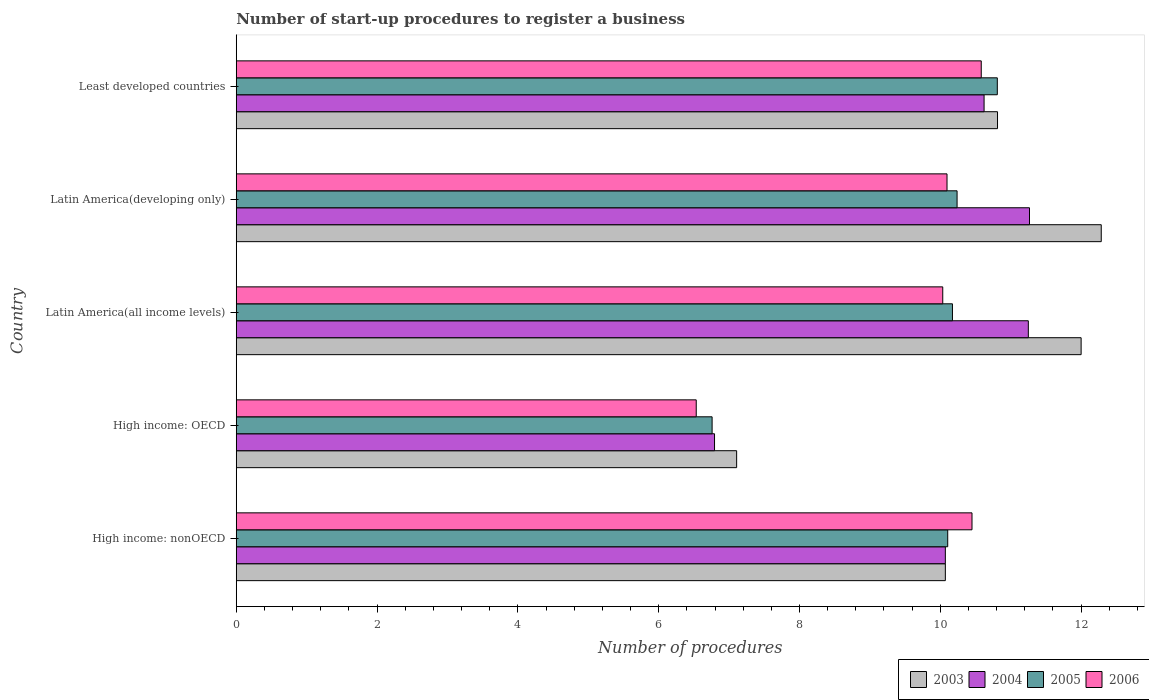How many different coloured bars are there?
Your answer should be very brief. 4. How many groups of bars are there?
Your answer should be very brief. 5. Are the number of bars on each tick of the Y-axis equal?
Provide a succinct answer. Yes. How many bars are there on the 1st tick from the top?
Make the answer very short. 4. How many bars are there on the 5th tick from the bottom?
Provide a short and direct response. 4. What is the label of the 1st group of bars from the top?
Make the answer very short. Least developed countries. In how many cases, is the number of bars for a given country not equal to the number of legend labels?
Keep it short and to the point. 0. What is the number of procedures required to register a business in 2006 in Latin America(all income levels)?
Provide a succinct answer. 10.03. Across all countries, what is the maximum number of procedures required to register a business in 2003?
Offer a terse response. 12.29. Across all countries, what is the minimum number of procedures required to register a business in 2005?
Offer a terse response. 6.76. In which country was the number of procedures required to register a business in 2006 maximum?
Ensure brevity in your answer.  Least developed countries. In which country was the number of procedures required to register a business in 2004 minimum?
Offer a very short reply. High income: OECD. What is the total number of procedures required to register a business in 2004 in the graph?
Your answer should be compact. 50. What is the difference between the number of procedures required to register a business in 2006 in High income: OECD and that in Latin America(developing only)?
Keep it short and to the point. -3.56. What is the difference between the number of procedures required to register a business in 2005 in Latin America(all income levels) and the number of procedures required to register a business in 2006 in Latin America(developing only)?
Your response must be concise. 0.08. What is the average number of procedures required to register a business in 2005 per country?
Provide a succinct answer. 9.62. What is the difference between the number of procedures required to register a business in 2003 and number of procedures required to register a business in 2006 in Latin America(developing only)?
Keep it short and to the point. 2.19. What is the ratio of the number of procedures required to register a business in 2003 in High income: OECD to that in Latin America(developing only)?
Provide a succinct answer. 0.58. What is the difference between the highest and the second highest number of procedures required to register a business in 2004?
Provide a succinct answer. 0.02. What is the difference between the highest and the lowest number of procedures required to register a business in 2005?
Offer a very short reply. 4.05. In how many countries, is the number of procedures required to register a business in 2005 greater than the average number of procedures required to register a business in 2005 taken over all countries?
Your answer should be compact. 4. Is the sum of the number of procedures required to register a business in 2005 in High income: OECD and Latin America(developing only) greater than the maximum number of procedures required to register a business in 2003 across all countries?
Offer a terse response. Yes. Is it the case that in every country, the sum of the number of procedures required to register a business in 2003 and number of procedures required to register a business in 2006 is greater than the sum of number of procedures required to register a business in 2004 and number of procedures required to register a business in 2005?
Offer a terse response. No. Is it the case that in every country, the sum of the number of procedures required to register a business in 2004 and number of procedures required to register a business in 2006 is greater than the number of procedures required to register a business in 2003?
Provide a succinct answer. Yes. How many bars are there?
Keep it short and to the point. 20. Are all the bars in the graph horizontal?
Ensure brevity in your answer.  Yes. How many countries are there in the graph?
Make the answer very short. 5. Are the values on the major ticks of X-axis written in scientific E-notation?
Keep it short and to the point. No. Does the graph contain grids?
Provide a succinct answer. No. How many legend labels are there?
Keep it short and to the point. 4. How are the legend labels stacked?
Keep it short and to the point. Horizontal. What is the title of the graph?
Your response must be concise. Number of start-up procedures to register a business. Does "1975" appear as one of the legend labels in the graph?
Offer a very short reply. No. What is the label or title of the X-axis?
Offer a terse response. Number of procedures. What is the label or title of the Y-axis?
Your answer should be compact. Country. What is the Number of procedures in 2003 in High income: nonOECD?
Your answer should be compact. 10.07. What is the Number of procedures in 2004 in High income: nonOECD?
Give a very brief answer. 10.07. What is the Number of procedures of 2005 in High income: nonOECD?
Your answer should be compact. 10.11. What is the Number of procedures of 2006 in High income: nonOECD?
Provide a succinct answer. 10.45. What is the Number of procedures in 2003 in High income: OECD?
Offer a very short reply. 7.11. What is the Number of procedures of 2004 in High income: OECD?
Keep it short and to the point. 6.79. What is the Number of procedures in 2005 in High income: OECD?
Offer a terse response. 6.76. What is the Number of procedures of 2006 in High income: OECD?
Provide a short and direct response. 6.53. What is the Number of procedures of 2004 in Latin America(all income levels)?
Your response must be concise. 11.25. What is the Number of procedures of 2005 in Latin America(all income levels)?
Ensure brevity in your answer.  10.17. What is the Number of procedures of 2006 in Latin America(all income levels)?
Provide a succinct answer. 10.03. What is the Number of procedures in 2003 in Latin America(developing only)?
Your answer should be compact. 12.29. What is the Number of procedures of 2004 in Latin America(developing only)?
Your answer should be very brief. 11.27. What is the Number of procedures of 2005 in Latin America(developing only)?
Provide a short and direct response. 10.24. What is the Number of procedures in 2006 in Latin America(developing only)?
Provide a succinct answer. 10.1. What is the Number of procedures of 2003 in Least developed countries?
Keep it short and to the point. 10.81. What is the Number of procedures of 2004 in Least developed countries?
Your response must be concise. 10.62. What is the Number of procedures of 2005 in Least developed countries?
Provide a succinct answer. 10.81. What is the Number of procedures in 2006 in Least developed countries?
Keep it short and to the point. 10.58. Across all countries, what is the maximum Number of procedures of 2003?
Make the answer very short. 12.29. Across all countries, what is the maximum Number of procedures in 2004?
Your response must be concise. 11.27. Across all countries, what is the maximum Number of procedures in 2005?
Provide a short and direct response. 10.81. Across all countries, what is the maximum Number of procedures in 2006?
Provide a succinct answer. 10.58. Across all countries, what is the minimum Number of procedures in 2003?
Your answer should be very brief. 7.11. Across all countries, what is the minimum Number of procedures in 2004?
Give a very brief answer. 6.79. Across all countries, what is the minimum Number of procedures of 2005?
Provide a short and direct response. 6.76. Across all countries, what is the minimum Number of procedures of 2006?
Provide a succinct answer. 6.53. What is the total Number of procedures in 2003 in the graph?
Give a very brief answer. 52.28. What is the total Number of procedures of 2004 in the graph?
Offer a terse response. 50. What is the total Number of procedures in 2005 in the graph?
Give a very brief answer. 48.08. What is the total Number of procedures in 2006 in the graph?
Provide a succinct answer. 47.69. What is the difference between the Number of procedures in 2003 in High income: nonOECD and that in High income: OECD?
Give a very brief answer. 2.96. What is the difference between the Number of procedures of 2004 in High income: nonOECD and that in High income: OECD?
Provide a short and direct response. 3.28. What is the difference between the Number of procedures in 2005 in High income: nonOECD and that in High income: OECD?
Give a very brief answer. 3.35. What is the difference between the Number of procedures in 2006 in High income: nonOECD and that in High income: OECD?
Your answer should be compact. 3.92. What is the difference between the Number of procedures in 2003 in High income: nonOECD and that in Latin America(all income levels)?
Make the answer very short. -1.93. What is the difference between the Number of procedures in 2004 in High income: nonOECD and that in Latin America(all income levels)?
Offer a very short reply. -1.18. What is the difference between the Number of procedures in 2005 in High income: nonOECD and that in Latin America(all income levels)?
Provide a succinct answer. -0.07. What is the difference between the Number of procedures in 2006 in High income: nonOECD and that in Latin America(all income levels)?
Make the answer very short. 0.42. What is the difference between the Number of procedures in 2003 in High income: nonOECD and that in Latin America(developing only)?
Offer a terse response. -2.21. What is the difference between the Number of procedures of 2004 in High income: nonOECD and that in Latin America(developing only)?
Offer a terse response. -1.2. What is the difference between the Number of procedures in 2005 in High income: nonOECD and that in Latin America(developing only)?
Offer a very short reply. -0.13. What is the difference between the Number of procedures in 2006 in High income: nonOECD and that in Latin America(developing only)?
Provide a short and direct response. 0.35. What is the difference between the Number of procedures of 2003 in High income: nonOECD and that in Least developed countries?
Ensure brevity in your answer.  -0.74. What is the difference between the Number of procedures of 2004 in High income: nonOECD and that in Least developed countries?
Give a very brief answer. -0.55. What is the difference between the Number of procedures of 2005 in High income: nonOECD and that in Least developed countries?
Provide a succinct answer. -0.7. What is the difference between the Number of procedures of 2006 in High income: nonOECD and that in Least developed countries?
Give a very brief answer. -0.13. What is the difference between the Number of procedures of 2003 in High income: OECD and that in Latin America(all income levels)?
Provide a short and direct response. -4.89. What is the difference between the Number of procedures of 2004 in High income: OECD and that in Latin America(all income levels)?
Offer a very short reply. -4.46. What is the difference between the Number of procedures in 2005 in High income: OECD and that in Latin America(all income levels)?
Your answer should be compact. -3.41. What is the difference between the Number of procedures of 2006 in High income: OECD and that in Latin America(all income levels)?
Your answer should be very brief. -3.5. What is the difference between the Number of procedures of 2003 in High income: OECD and that in Latin America(developing only)?
Offer a very short reply. -5.18. What is the difference between the Number of procedures in 2004 in High income: OECD and that in Latin America(developing only)?
Ensure brevity in your answer.  -4.47. What is the difference between the Number of procedures in 2005 in High income: OECD and that in Latin America(developing only)?
Your response must be concise. -3.48. What is the difference between the Number of procedures in 2006 in High income: OECD and that in Latin America(developing only)?
Your response must be concise. -3.56. What is the difference between the Number of procedures in 2003 in High income: OECD and that in Least developed countries?
Offer a very short reply. -3.71. What is the difference between the Number of procedures of 2004 in High income: OECD and that in Least developed countries?
Make the answer very short. -3.83. What is the difference between the Number of procedures of 2005 in High income: OECD and that in Least developed countries?
Provide a short and direct response. -4.05. What is the difference between the Number of procedures in 2006 in High income: OECD and that in Least developed countries?
Provide a short and direct response. -4.05. What is the difference between the Number of procedures of 2003 in Latin America(all income levels) and that in Latin America(developing only)?
Provide a succinct answer. -0.29. What is the difference between the Number of procedures in 2004 in Latin America(all income levels) and that in Latin America(developing only)?
Ensure brevity in your answer.  -0.02. What is the difference between the Number of procedures of 2005 in Latin America(all income levels) and that in Latin America(developing only)?
Offer a terse response. -0.07. What is the difference between the Number of procedures of 2006 in Latin America(all income levels) and that in Latin America(developing only)?
Your answer should be compact. -0.06. What is the difference between the Number of procedures in 2003 in Latin America(all income levels) and that in Least developed countries?
Ensure brevity in your answer.  1.19. What is the difference between the Number of procedures in 2004 in Latin America(all income levels) and that in Least developed countries?
Ensure brevity in your answer.  0.63. What is the difference between the Number of procedures in 2005 in Latin America(all income levels) and that in Least developed countries?
Provide a succinct answer. -0.64. What is the difference between the Number of procedures in 2006 in Latin America(all income levels) and that in Least developed countries?
Offer a terse response. -0.55. What is the difference between the Number of procedures of 2003 in Latin America(developing only) and that in Least developed countries?
Provide a short and direct response. 1.47. What is the difference between the Number of procedures in 2004 in Latin America(developing only) and that in Least developed countries?
Your answer should be very brief. 0.65. What is the difference between the Number of procedures of 2005 in Latin America(developing only) and that in Least developed countries?
Ensure brevity in your answer.  -0.57. What is the difference between the Number of procedures in 2006 in Latin America(developing only) and that in Least developed countries?
Your answer should be very brief. -0.49. What is the difference between the Number of procedures in 2003 in High income: nonOECD and the Number of procedures in 2004 in High income: OECD?
Give a very brief answer. 3.28. What is the difference between the Number of procedures of 2003 in High income: nonOECD and the Number of procedures of 2005 in High income: OECD?
Ensure brevity in your answer.  3.31. What is the difference between the Number of procedures in 2003 in High income: nonOECD and the Number of procedures in 2006 in High income: OECD?
Offer a terse response. 3.54. What is the difference between the Number of procedures in 2004 in High income: nonOECD and the Number of procedures in 2005 in High income: OECD?
Your answer should be compact. 3.31. What is the difference between the Number of procedures in 2004 in High income: nonOECD and the Number of procedures in 2006 in High income: OECD?
Keep it short and to the point. 3.54. What is the difference between the Number of procedures of 2005 in High income: nonOECD and the Number of procedures of 2006 in High income: OECD?
Offer a very short reply. 3.57. What is the difference between the Number of procedures in 2003 in High income: nonOECD and the Number of procedures in 2004 in Latin America(all income levels)?
Your answer should be very brief. -1.18. What is the difference between the Number of procedures of 2003 in High income: nonOECD and the Number of procedures of 2005 in Latin America(all income levels)?
Ensure brevity in your answer.  -0.1. What is the difference between the Number of procedures of 2003 in High income: nonOECD and the Number of procedures of 2006 in Latin America(all income levels)?
Make the answer very short. 0.04. What is the difference between the Number of procedures in 2004 in High income: nonOECD and the Number of procedures in 2005 in Latin America(all income levels)?
Offer a very short reply. -0.1. What is the difference between the Number of procedures in 2004 in High income: nonOECD and the Number of procedures in 2006 in Latin America(all income levels)?
Offer a very short reply. 0.04. What is the difference between the Number of procedures of 2005 in High income: nonOECD and the Number of procedures of 2006 in Latin America(all income levels)?
Your answer should be very brief. 0.07. What is the difference between the Number of procedures in 2003 in High income: nonOECD and the Number of procedures in 2004 in Latin America(developing only)?
Make the answer very short. -1.2. What is the difference between the Number of procedures in 2003 in High income: nonOECD and the Number of procedures in 2006 in Latin America(developing only)?
Ensure brevity in your answer.  -0.02. What is the difference between the Number of procedures of 2004 in High income: nonOECD and the Number of procedures of 2006 in Latin America(developing only)?
Your answer should be compact. -0.02. What is the difference between the Number of procedures in 2005 in High income: nonOECD and the Number of procedures in 2006 in Latin America(developing only)?
Your answer should be compact. 0.01. What is the difference between the Number of procedures in 2003 in High income: nonOECD and the Number of procedures in 2004 in Least developed countries?
Keep it short and to the point. -0.55. What is the difference between the Number of procedures in 2003 in High income: nonOECD and the Number of procedures in 2005 in Least developed countries?
Your response must be concise. -0.74. What is the difference between the Number of procedures in 2003 in High income: nonOECD and the Number of procedures in 2006 in Least developed countries?
Ensure brevity in your answer.  -0.51. What is the difference between the Number of procedures in 2004 in High income: nonOECD and the Number of procedures in 2005 in Least developed countries?
Your answer should be compact. -0.74. What is the difference between the Number of procedures of 2004 in High income: nonOECD and the Number of procedures of 2006 in Least developed countries?
Offer a very short reply. -0.51. What is the difference between the Number of procedures in 2005 in High income: nonOECD and the Number of procedures in 2006 in Least developed countries?
Offer a very short reply. -0.48. What is the difference between the Number of procedures in 2003 in High income: OECD and the Number of procedures in 2004 in Latin America(all income levels)?
Ensure brevity in your answer.  -4.14. What is the difference between the Number of procedures in 2003 in High income: OECD and the Number of procedures in 2005 in Latin America(all income levels)?
Your answer should be compact. -3.07. What is the difference between the Number of procedures in 2003 in High income: OECD and the Number of procedures in 2006 in Latin America(all income levels)?
Provide a succinct answer. -2.93. What is the difference between the Number of procedures of 2004 in High income: OECD and the Number of procedures of 2005 in Latin America(all income levels)?
Your answer should be compact. -3.38. What is the difference between the Number of procedures of 2004 in High income: OECD and the Number of procedures of 2006 in Latin America(all income levels)?
Provide a succinct answer. -3.24. What is the difference between the Number of procedures of 2005 in High income: OECD and the Number of procedures of 2006 in Latin America(all income levels)?
Make the answer very short. -3.28. What is the difference between the Number of procedures in 2003 in High income: OECD and the Number of procedures in 2004 in Latin America(developing only)?
Keep it short and to the point. -4.16. What is the difference between the Number of procedures in 2003 in High income: OECD and the Number of procedures in 2005 in Latin America(developing only)?
Offer a very short reply. -3.13. What is the difference between the Number of procedures of 2003 in High income: OECD and the Number of procedures of 2006 in Latin America(developing only)?
Give a very brief answer. -2.99. What is the difference between the Number of procedures in 2004 in High income: OECD and the Number of procedures in 2005 in Latin America(developing only)?
Make the answer very short. -3.44. What is the difference between the Number of procedures in 2004 in High income: OECD and the Number of procedures in 2006 in Latin America(developing only)?
Give a very brief answer. -3.3. What is the difference between the Number of procedures in 2005 in High income: OECD and the Number of procedures in 2006 in Latin America(developing only)?
Offer a very short reply. -3.34. What is the difference between the Number of procedures of 2003 in High income: OECD and the Number of procedures of 2004 in Least developed countries?
Give a very brief answer. -3.51. What is the difference between the Number of procedures in 2003 in High income: OECD and the Number of procedures in 2005 in Least developed countries?
Offer a terse response. -3.7. What is the difference between the Number of procedures of 2003 in High income: OECD and the Number of procedures of 2006 in Least developed countries?
Provide a succinct answer. -3.47. What is the difference between the Number of procedures in 2004 in High income: OECD and the Number of procedures in 2005 in Least developed countries?
Ensure brevity in your answer.  -4.02. What is the difference between the Number of procedures of 2004 in High income: OECD and the Number of procedures of 2006 in Least developed countries?
Your response must be concise. -3.79. What is the difference between the Number of procedures in 2005 in High income: OECD and the Number of procedures in 2006 in Least developed countries?
Ensure brevity in your answer.  -3.82. What is the difference between the Number of procedures of 2003 in Latin America(all income levels) and the Number of procedures of 2004 in Latin America(developing only)?
Provide a short and direct response. 0.73. What is the difference between the Number of procedures in 2003 in Latin America(all income levels) and the Number of procedures in 2005 in Latin America(developing only)?
Make the answer very short. 1.76. What is the difference between the Number of procedures of 2003 in Latin America(all income levels) and the Number of procedures of 2006 in Latin America(developing only)?
Offer a terse response. 1.9. What is the difference between the Number of procedures of 2004 in Latin America(all income levels) and the Number of procedures of 2005 in Latin America(developing only)?
Provide a succinct answer. 1.01. What is the difference between the Number of procedures of 2004 in Latin America(all income levels) and the Number of procedures of 2006 in Latin America(developing only)?
Give a very brief answer. 1.15. What is the difference between the Number of procedures of 2005 in Latin America(all income levels) and the Number of procedures of 2006 in Latin America(developing only)?
Your response must be concise. 0.08. What is the difference between the Number of procedures in 2003 in Latin America(all income levels) and the Number of procedures in 2004 in Least developed countries?
Your answer should be compact. 1.38. What is the difference between the Number of procedures of 2003 in Latin America(all income levels) and the Number of procedures of 2005 in Least developed countries?
Provide a short and direct response. 1.19. What is the difference between the Number of procedures of 2003 in Latin America(all income levels) and the Number of procedures of 2006 in Least developed countries?
Offer a terse response. 1.42. What is the difference between the Number of procedures of 2004 in Latin America(all income levels) and the Number of procedures of 2005 in Least developed countries?
Your answer should be compact. 0.44. What is the difference between the Number of procedures of 2004 in Latin America(all income levels) and the Number of procedures of 2006 in Least developed countries?
Give a very brief answer. 0.67. What is the difference between the Number of procedures of 2005 in Latin America(all income levels) and the Number of procedures of 2006 in Least developed countries?
Ensure brevity in your answer.  -0.41. What is the difference between the Number of procedures in 2003 in Latin America(developing only) and the Number of procedures in 2004 in Least developed countries?
Give a very brief answer. 1.66. What is the difference between the Number of procedures in 2003 in Latin America(developing only) and the Number of procedures in 2005 in Least developed countries?
Ensure brevity in your answer.  1.48. What is the difference between the Number of procedures of 2003 in Latin America(developing only) and the Number of procedures of 2006 in Least developed countries?
Offer a very short reply. 1.7. What is the difference between the Number of procedures of 2004 in Latin America(developing only) and the Number of procedures of 2005 in Least developed countries?
Keep it short and to the point. 0.46. What is the difference between the Number of procedures in 2004 in Latin America(developing only) and the Number of procedures in 2006 in Least developed countries?
Provide a short and direct response. 0.69. What is the difference between the Number of procedures in 2005 in Latin America(developing only) and the Number of procedures in 2006 in Least developed countries?
Provide a short and direct response. -0.34. What is the average Number of procedures in 2003 per country?
Give a very brief answer. 10.46. What is the average Number of procedures in 2004 per country?
Ensure brevity in your answer.  10. What is the average Number of procedures of 2005 per country?
Provide a succinct answer. 9.62. What is the average Number of procedures in 2006 per country?
Ensure brevity in your answer.  9.54. What is the difference between the Number of procedures in 2003 and Number of procedures in 2004 in High income: nonOECD?
Provide a succinct answer. 0. What is the difference between the Number of procedures of 2003 and Number of procedures of 2005 in High income: nonOECD?
Provide a succinct answer. -0.03. What is the difference between the Number of procedures in 2003 and Number of procedures in 2006 in High income: nonOECD?
Make the answer very short. -0.38. What is the difference between the Number of procedures of 2004 and Number of procedures of 2005 in High income: nonOECD?
Offer a very short reply. -0.03. What is the difference between the Number of procedures of 2004 and Number of procedures of 2006 in High income: nonOECD?
Provide a short and direct response. -0.38. What is the difference between the Number of procedures of 2005 and Number of procedures of 2006 in High income: nonOECD?
Make the answer very short. -0.34. What is the difference between the Number of procedures in 2003 and Number of procedures in 2004 in High income: OECD?
Your answer should be compact. 0.31. What is the difference between the Number of procedures in 2003 and Number of procedures in 2005 in High income: OECD?
Provide a succinct answer. 0.35. What is the difference between the Number of procedures in 2003 and Number of procedures in 2006 in High income: OECD?
Your response must be concise. 0.57. What is the difference between the Number of procedures of 2004 and Number of procedures of 2005 in High income: OECD?
Your answer should be very brief. 0.03. What is the difference between the Number of procedures of 2004 and Number of procedures of 2006 in High income: OECD?
Ensure brevity in your answer.  0.26. What is the difference between the Number of procedures of 2005 and Number of procedures of 2006 in High income: OECD?
Your answer should be compact. 0.23. What is the difference between the Number of procedures in 2003 and Number of procedures in 2004 in Latin America(all income levels)?
Offer a very short reply. 0.75. What is the difference between the Number of procedures of 2003 and Number of procedures of 2005 in Latin America(all income levels)?
Give a very brief answer. 1.83. What is the difference between the Number of procedures of 2003 and Number of procedures of 2006 in Latin America(all income levels)?
Ensure brevity in your answer.  1.97. What is the difference between the Number of procedures of 2004 and Number of procedures of 2005 in Latin America(all income levels)?
Offer a very short reply. 1.08. What is the difference between the Number of procedures of 2004 and Number of procedures of 2006 in Latin America(all income levels)?
Your answer should be very brief. 1.22. What is the difference between the Number of procedures in 2005 and Number of procedures in 2006 in Latin America(all income levels)?
Provide a succinct answer. 0.14. What is the difference between the Number of procedures of 2003 and Number of procedures of 2005 in Latin America(developing only)?
Ensure brevity in your answer.  2.05. What is the difference between the Number of procedures of 2003 and Number of procedures of 2006 in Latin America(developing only)?
Your answer should be compact. 2.19. What is the difference between the Number of procedures of 2004 and Number of procedures of 2005 in Latin America(developing only)?
Your answer should be very brief. 1.03. What is the difference between the Number of procedures in 2004 and Number of procedures in 2006 in Latin America(developing only)?
Your answer should be very brief. 1.17. What is the difference between the Number of procedures in 2005 and Number of procedures in 2006 in Latin America(developing only)?
Your answer should be very brief. 0.14. What is the difference between the Number of procedures of 2003 and Number of procedures of 2004 in Least developed countries?
Provide a succinct answer. 0.19. What is the difference between the Number of procedures of 2003 and Number of procedures of 2005 in Least developed countries?
Your response must be concise. 0. What is the difference between the Number of procedures of 2003 and Number of procedures of 2006 in Least developed countries?
Keep it short and to the point. 0.23. What is the difference between the Number of procedures of 2004 and Number of procedures of 2005 in Least developed countries?
Make the answer very short. -0.19. What is the difference between the Number of procedures in 2004 and Number of procedures in 2006 in Least developed countries?
Your answer should be very brief. 0.04. What is the difference between the Number of procedures of 2005 and Number of procedures of 2006 in Least developed countries?
Offer a very short reply. 0.23. What is the ratio of the Number of procedures in 2003 in High income: nonOECD to that in High income: OECD?
Provide a succinct answer. 1.42. What is the ratio of the Number of procedures in 2004 in High income: nonOECD to that in High income: OECD?
Your answer should be very brief. 1.48. What is the ratio of the Number of procedures in 2005 in High income: nonOECD to that in High income: OECD?
Give a very brief answer. 1.5. What is the ratio of the Number of procedures of 2006 in High income: nonOECD to that in High income: OECD?
Your response must be concise. 1.6. What is the ratio of the Number of procedures of 2003 in High income: nonOECD to that in Latin America(all income levels)?
Give a very brief answer. 0.84. What is the ratio of the Number of procedures of 2004 in High income: nonOECD to that in Latin America(all income levels)?
Provide a short and direct response. 0.9. What is the ratio of the Number of procedures in 2005 in High income: nonOECD to that in Latin America(all income levels)?
Provide a short and direct response. 0.99. What is the ratio of the Number of procedures in 2006 in High income: nonOECD to that in Latin America(all income levels)?
Provide a short and direct response. 1.04. What is the ratio of the Number of procedures in 2003 in High income: nonOECD to that in Latin America(developing only)?
Your response must be concise. 0.82. What is the ratio of the Number of procedures of 2004 in High income: nonOECD to that in Latin America(developing only)?
Your response must be concise. 0.89. What is the ratio of the Number of procedures in 2006 in High income: nonOECD to that in Latin America(developing only)?
Provide a short and direct response. 1.04. What is the ratio of the Number of procedures in 2003 in High income: nonOECD to that in Least developed countries?
Keep it short and to the point. 0.93. What is the ratio of the Number of procedures in 2004 in High income: nonOECD to that in Least developed countries?
Provide a short and direct response. 0.95. What is the ratio of the Number of procedures in 2005 in High income: nonOECD to that in Least developed countries?
Your answer should be compact. 0.93. What is the ratio of the Number of procedures in 2006 in High income: nonOECD to that in Least developed countries?
Keep it short and to the point. 0.99. What is the ratio of the Number of procedures in 2003 in High income: OECD to that in Latin America(all income levels)?
Your answer should be compact. 0.59. What is the ratio of the Number of procedures in 2004 in High income: OECD to that in Latin America(all income levels)?
Ensure brevity in your answer.  0.6. What is the ratio of the Number of procedures of 2005 in High income: OECD to that in Latin America(all income levels)?
Provide a short and direct response. 0.66. What is the ratio of the Number of procedures of 2006 in High income: OECD to that in Latin America(all income levels)?
Make the answer very short. 0.65. What is the ratio of the Number of procedures in 2003 in High income: OECD to that in Latin America(developing only)?
Keep it short and to the point. 0.58. What is the ratio of the Number of procedures of 2004 in High income: OECD to that in Latin America(developing only)?
Ensure brevity in your answer.  0.6. What is the ratio of the Number of procedures in 2005 in High income: OECD to that in Latin America(developing only)?
Keep it short and to the point. 0.66. What is the ratio of the Number of procedures in 2006 in High income: OECD to that in Latin America(developing only)?
Your answer should be compact. 0.65. What is the ratio of the Number of procedures in 2003 in High income: OECD to that in Least developed countries?
Your answer should be very brief. 0.66. What is the ratio of the Number of procedures in 2004 in High income: OECD to that in Least developed countries?
Keep it short and to the point. 0.64. What is the ratio of the Number of procedures in 2005 in High income: OECD to that in Least developed countries?
Offer a terse response. 0.63. What is the ratio of the Number of procedures of 2006 in High income: OECD to that in Least developed countries?
Ensure brevity in your answer.  0.62. What is the ratio of the Number of procedures in 2003 in Latin America(all income levels) to that in Latin America(developing only)?
Your answer should be very brief. 0.98. What is the ratio of the Number of procedures in 2004 in Latin America(all income levels) to that in Latin America(developing only)?
Ensure brevity in your answer.  1. What is the ratio of the Number of procedures of 2006 in Latin America(all income levels) to that in Latin America(developing only)?
Provide a succinct answer. 0.99. What is the ratio of the Number of procedures of 2003 in Latin America(all income levels) to that in Least developed countries?
Provide a succinct answer. 1.11. What is the ratio of the Number of procedures in 2004 in Latin America(all income levels) to that in Least developed countries?
Give a very brief answer. 1.06. What is the ratio of the Number of procedures in 2005 in Latin America(all income levels) to that in Least developed countries?
Ensure brevity in your answer.  0.94. What is the ratio of the Number of procedures of 2006 in Latin America(all income levels) to that in Least developed countries?
Provide a succinct answer. 0.95. What is the ratio of the Number of procedures of 2003 in Latin America(developing only) to that in Least developed countries?
Your response must be concise. 1.14. What is the ratio of the Number of procedures in 2004 in Latin America(developing only) to that in Least developed countries?
Offer a very short reply. 1.06. What is the ratio of the Number of procedures in 2005 in Latin America(developing only) to that in Least developed countries?
Provide a short and direct response. 0.95. What is the ratio of the Number of procedures in 2006 in Latin America(developing only) to that in Least developed countries?
Offer a very short reply. 0.95. What is the difference between the highest and the second highest Number of procedures of 2003?
Your answer should be compact. 0.29. What is the difference between the highest and the second highest Number of procedures in 2004?
Provide a succinct answer. 0.02. What is the difference between the highest and the second highest Number of procedures in 2005?
Give a very brief answer. 0.57. What is the difference between the highest and the second highest Number of procedures of 2006?
Offer a very short reply. 0.13. What is the difference between the highest and the lowest Number of procedures of 2003?
Your answer should be very brief. 5.18. What is the difference between the highest and the lowest Number of procedures in 2004?
Give a very brief answer. 4.47. What is the difference between the highest and the lowest Number of procedures in 2005?
Offer a terse response. 4.05. What is the difference between the highest and the lowest Number of procedures of 2006?
Offer a very short reply. 4.05. 